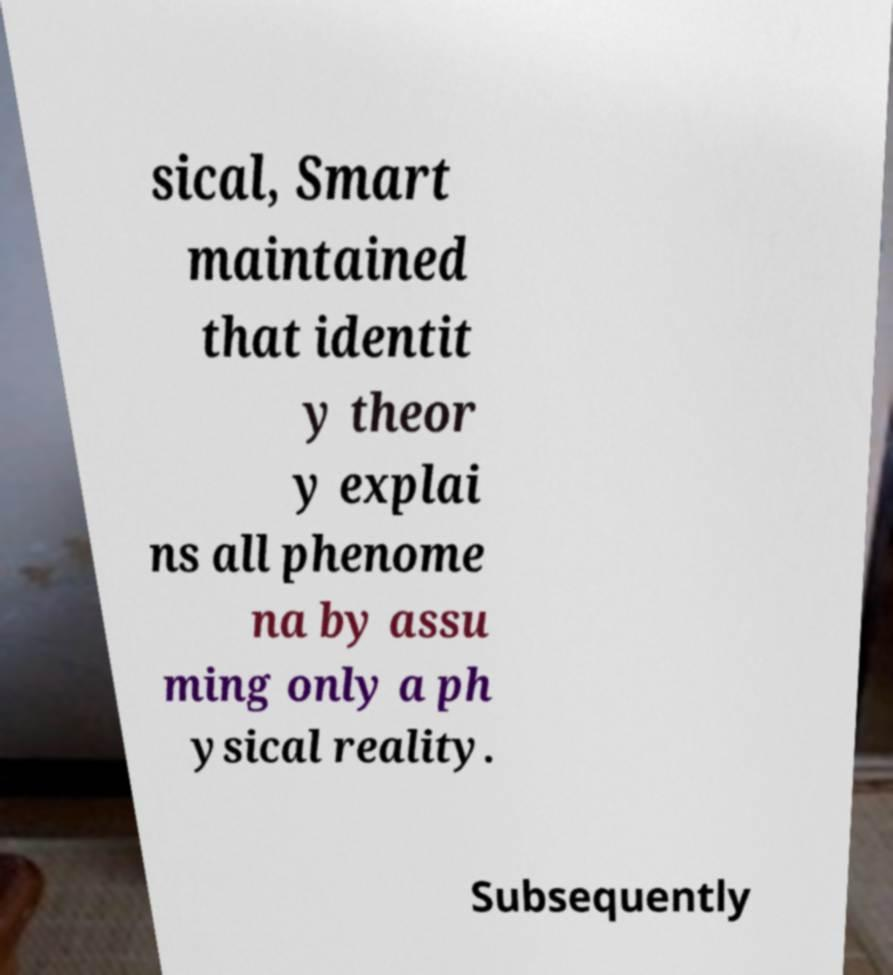I need the written content from this picture converted into text. Can you do that? sical, Smart maintained that identit y theor y explai ns all phenome na by assu ming only a ph ysical reality. Subsequently 